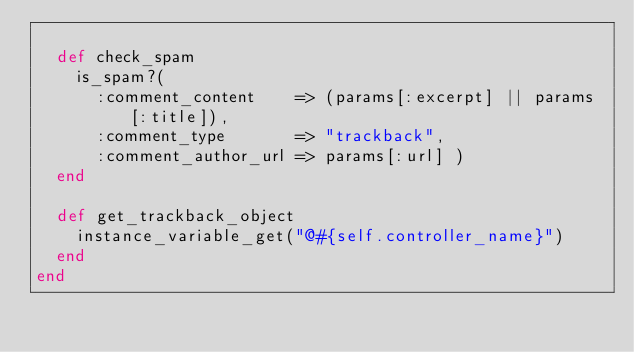<code> <loc_0><loc_0><loc_500><loc_500><_Ruby_>  
  def check_spam
    is_spam?(
      :comment_content    => (params[:excerpt] || params[:title]),
      :comment_type       => "trackback",
      :comment_author_url => params[:url] )
  end

  def get_trackback_object
    instance_variable_get("@#{self.controller_name}")
  end
end
</code> 